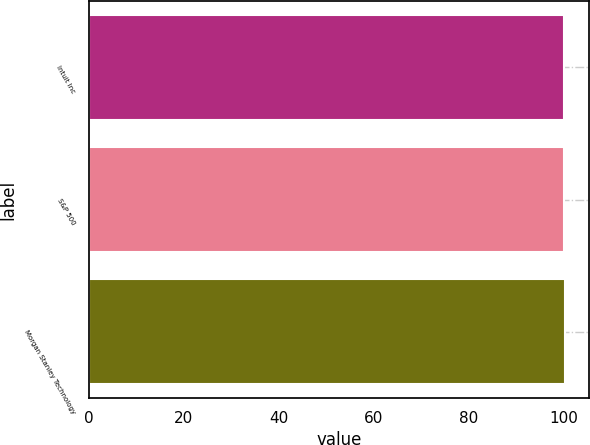Convert chart to OTSL. <chart><loc_0><loc_0><loc_500><loc_500><bar_chart><fcel>Intuit Inc<fcel>S&P 500<fcel>Morgan Stanley Technology<nl><fcel>100<fcel>100.1<fcel>100.2<nl></chart> 